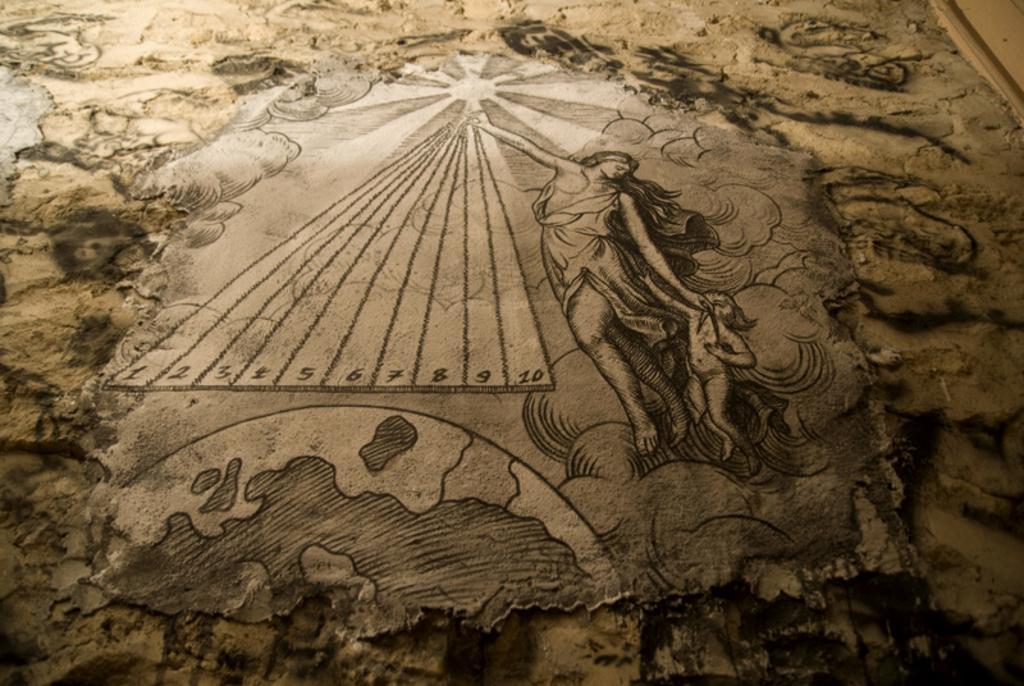Could you give a brief overview of what you see in this image? In this image, we can see a wall art. In this wall, we can see few people, globe, numbers, sun rays. 